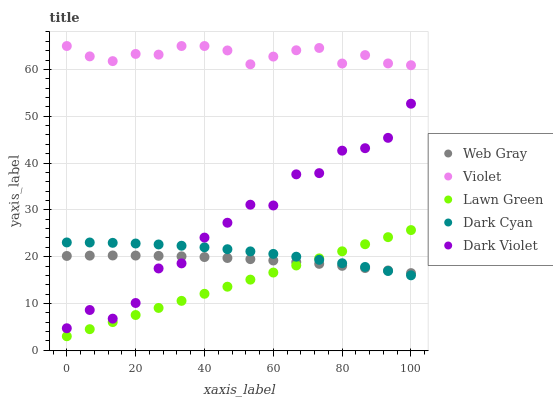Does Lawn Green have the minimum area under the curve?
Answer yes or no. Yes. Does Violet have the maximum area under the curve?
Answer yes or no. Yes. Does Web Gray have the minimum area under the curve?
Answer yes or no. No. Does Web Gray have the maximum area under the curve?
Answer yes or no. No. Is Lawn Green the smoothest?
Answer yes or no. Yes. Is Dark Violet the roughest?
Answer yes or no. Yes. Is Web Gray the smoothest?
Answer yes or no. No. Is Web Gray the roughest?
Answer yes or no. No. Does Lawn Green have the lowest value?
Answer yes or no. Yes. Does Web Gray have the lowest value?
Answer yes or no. No. Does Violet have the highest value?
Answer yes or no. Yes. Does Lawn Green have the highest value?
Answer yes or no. No. Is Lawn Green less than Dark Violet?
Answer yes or no. Yes. Is Violet greater than Web Gray?
Answer yes or no. Yes. Does Lawn Green intersect Web Gray?
Answer yes or no. Yes. Is Lawn Green less than Web Gray?
Answer yes or no. No. Is Lawn Green greater than Web Gray?
Answer yes or no. No. Does Lawn Green intersect Dark Violet?
Answer yes or no. No. 